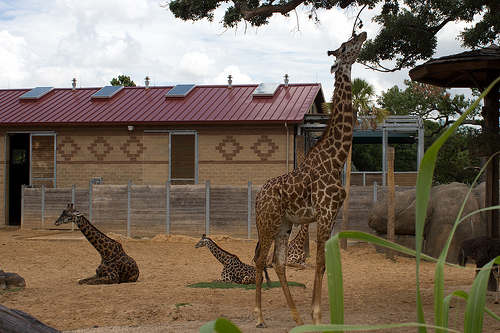Please provide a short description for this region: [0.36, 0.63, 0.51, 0.74]. The region with coordinates [0.36, 0.63, 0.51, 0.74] depicts a small giraffe lying on the ground. 